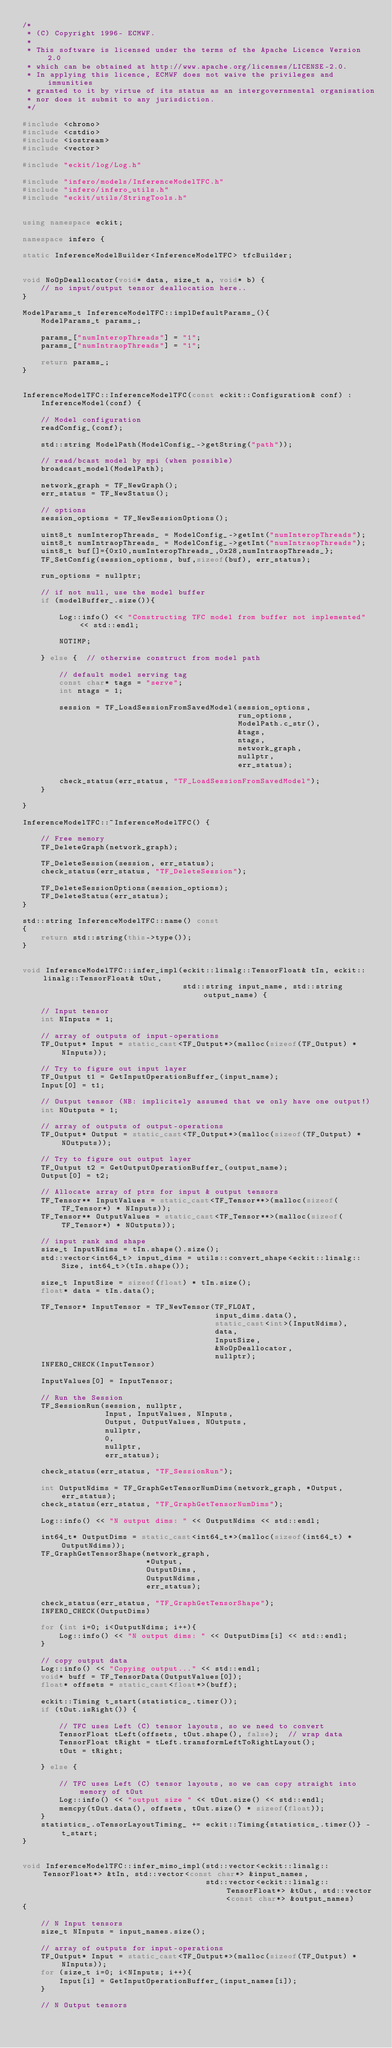<code> <loc_0><loc_0><loc_500><loc_500><_C++_>/*
 * (C) Copyright 1996- ECMWF.
 *
 * This software is licensed under the terms of the Apache Licence Version 2.0
 * which can be obtained at http://www.apache.org/licenses/LICENSE-2.0.
 * In applying this licence, ECMWF does not waive the privileges and immunities
 * granted to it by virtue of its status as an intergovernmental organisation
 * nor does it submit to any jurisdiction.
 */

#include <chrono>
#include <cstdio>
#include <iostream>
#include <vector>

#include "eckit/log/Log.h"

#include "infero/models/InferenceModelTFC.h"
#include "infero/infero_utils.h"
#include "eckit/utils/StringTools.h"


using namespace eckit;

namespace infero {

static InferenceModelBuilder<InferenceModelTFC> tfcBuilder;


void NoOpDeallocator(void* data, size_t a, void* b) {
    // no input/output tensor deallocation here..
}

ModelParams_t InferenceModelTFC::implDefaultParams_(){
    ModelParams_t params_;
       
    params_["numInteropThreads"] = "1";
    params_["numIntraopThreads"] = "1";

    return params_;
}


InferenceModelTFC::InferenceModelTFC(const eckit::Configuration& conf) :
    InferenceModel(conf) {

    // Model configuration
    readConfig_(conf);

    std::string ModelPath(ModelConfig_->getString("path"));

    // read/bcast model by mpi (when possible)
    broadcast_model(ModelPath);

    network_graph = TF_NewGraph();
    err_status = TF_NewStatus();

    // options
    session_options = TF_NewSessionOptions();

    uint8_t numInteropThreads_ = ModelConfig_->getInt("numInteropThreads");
    uint8_t numIntraopThreads_ = ModelConfig_->getInt("numIntraopThreads");
    uint8_t buf[]={0x10,numInteropThreads_,0x28,numIntraopThreads_};
    TF_SetConfig(session_options, buf,sizeof(buf), err_status);    

    run_options = nullptr;

    // if not null, use the model buffer
    if (modelBuffer_.size()){

        Log::info() << "Constructing TFC model from buffer not implemented" << std::endl;

        NOTIMP;

    } else {  // otherwise construct from model path

        // default model serving tag
        const char* tags = "serve";
        int ntags = 1;

        session = TF_LoadSessionFromSavedModel(session_options,
                                               run_options,
                                               ModelPath.c_str(),
                                               &tags,
                                               ntags,
                                               network_graph,
                                               nullptr,
                                               err_status);

        check_status(err_status, "TF_LoadSessionFromSavedModel");
    }

}

InferenceModelTFC::~InferenceModelTFC() {

    // Free memory
    TF_DeleteGraph(network_graph);

    TF_DeleteSession(session, err_status);
    check_status(err_status, "TF_DeleteSession");

    TF_DeleteSessionOptions(session_options);
    TF_DeleteStatus(err_status);
}

std::string InferenceModelTFC::name() const
{
    return std::string(this->type());
}


void InferenceModelTFC::infer_impl(eckit::linalg::TensorFloat& tIn, eckit::linalg::TensorFloat& tOut,
                                   std::string input_name, std::string output_name) {

    // Input tensor
    int NInputs = 1;

    // array of outputs of input-operations
    TF_Output* Input = static_cast<TF_Output*>(malloc(sizeof(TF_Output) * NInputs));

    // Try to figure out input layer
    TF_Output t1 = GetInputOperationBuffer_(input_name);
    Input[0] = t1;

    // Output tensor (NB: implicitely assumed that we only have one output!)
    int NOutputs = 1;

    // array of outputs of output-operations
    TF_Output* Output = static_cast<TF_Output*>(malloc(sizeof(TF_Output) * NOutputs));

    // Try to figure out output layer
    TF_Output t2 = GetOutputOperationBuffer_(output_name);
    Output[0] = t2;

    // Allocate array of ptrs for input & output tensors
    TF_Tensor** InputValues = static_cast<TF_Tensor**>(malloc(sizeof(TF_Tensor*) * NInputs));
    TF_Tensor** OutputValues = static_cast<TF_Tensor**>(malloc(sizeof(TF_Tensor*) * NOutputs));

    // input rank and shape
    size_t InputNdims = tIn.shape().size();
    std::vector<int64_t> input_dims = utils::convert_shape<eckit::linalg::Size, int64_t>(tIn.shape());

    size_t InputSize = sizeof(float) * tIn.size();
    float* data = tIn.data();

    TF_Tensor* InputTensor = TF_NewTensor(TF_FLOAT,
                                          input_dims.data(),
                                          static_cast<int>(InputNdims),
                                          data,
                                          InputSize,
                                          &NoOpDeallocator,
                                          nullptr);
    INFERO_CHECK(InputTensor)

    InputValues[0] = InputTensor;

    // Run the Session
    TF_SessionRun(session, nullptr,
                  Input, InputValues, NInputs,
                  Output, OutputValues, NOutputs,
                  nullptr,
                  0,
                  nullptr,
                  err_status);

    check_status(err_status, "TF_SessionRun");

    int OutputNdims = TF_GraphGetTensorNumDims(network_graph, *Output, err_status);
    check_status(err_status, "TF_GraphGetTensorNumDims");

    Log::info() << "N output dims: " << OutputNdims << std::endl;

    int64_t* OutputDims = static_cast<int64_t*>(malloc(sizeof(int64_t) * OutputNdims));
    TF_GraphGetTensorShape(network_graph,
                           *Output,
                           OutputDims,
                           OutputNdims,
                           err_status);

    check_status(err_status, "TF_GraphGetTensorShape");
    INFERO_CHECK(OutputDims)

    for (int i=0; i<OutputNdims; i++){
        Log::info() << "N output dims: " << OutputDims[i] << std::endl;
    }

    // copy output data
    Log::info() << "Copying output..." << std::endl;
    void* buff = TF_TensorData(OutputValues[0]);
    float* offsets = static_cast<float*>(buff);

    eckit::Timing t_start(statistics_.timer());
    if (tOut.isRight()) {

        // TFC uses Left (C) tensor layouts, so we need to convert
        TensorFloat tLeft(offsets, tOut.shape(), false);  // wrap data        
        TensorFloat tRight = tLeft.transformLeftToRightLayout();
        tOut = tRight;

    } else {

        // TFC uses Left (C) tensor layouts, so we can copy straight into memory of tOut
        Log::info() << "output size " << tOut.size() << std::endl;
        memcpy(tOut.data(), offsets, tOut.size() * sizeof(float));
    }
    statistics_.oTensorLayoutTiming_ += eckit::Timing{statistics_.timer()} - t_start;
}


void InferenceModelTFC::infer_mimo_impl(std::vector<eckit::linalg::TensorFloat*> &tIn, std::vector<const char*> &input_names,
                                        std::vector<eckit::linalg::TensorFloat*> &tOut, std::vector<const char*> &output_names)
{

    // N Input tensors
    size_t NInputs = input_names.size();

    // array of outputs for input-operations
    TF_Output* Input = static_cast<TF_Output*>(malloc(sizeof(TF_Output) * NInputs));
    for (size_t i=0; i<NInputs; i++){
        Input[i] = GetInputOperationBuffer_(input_names[i]);
    }

    // N Output tensors</code> 